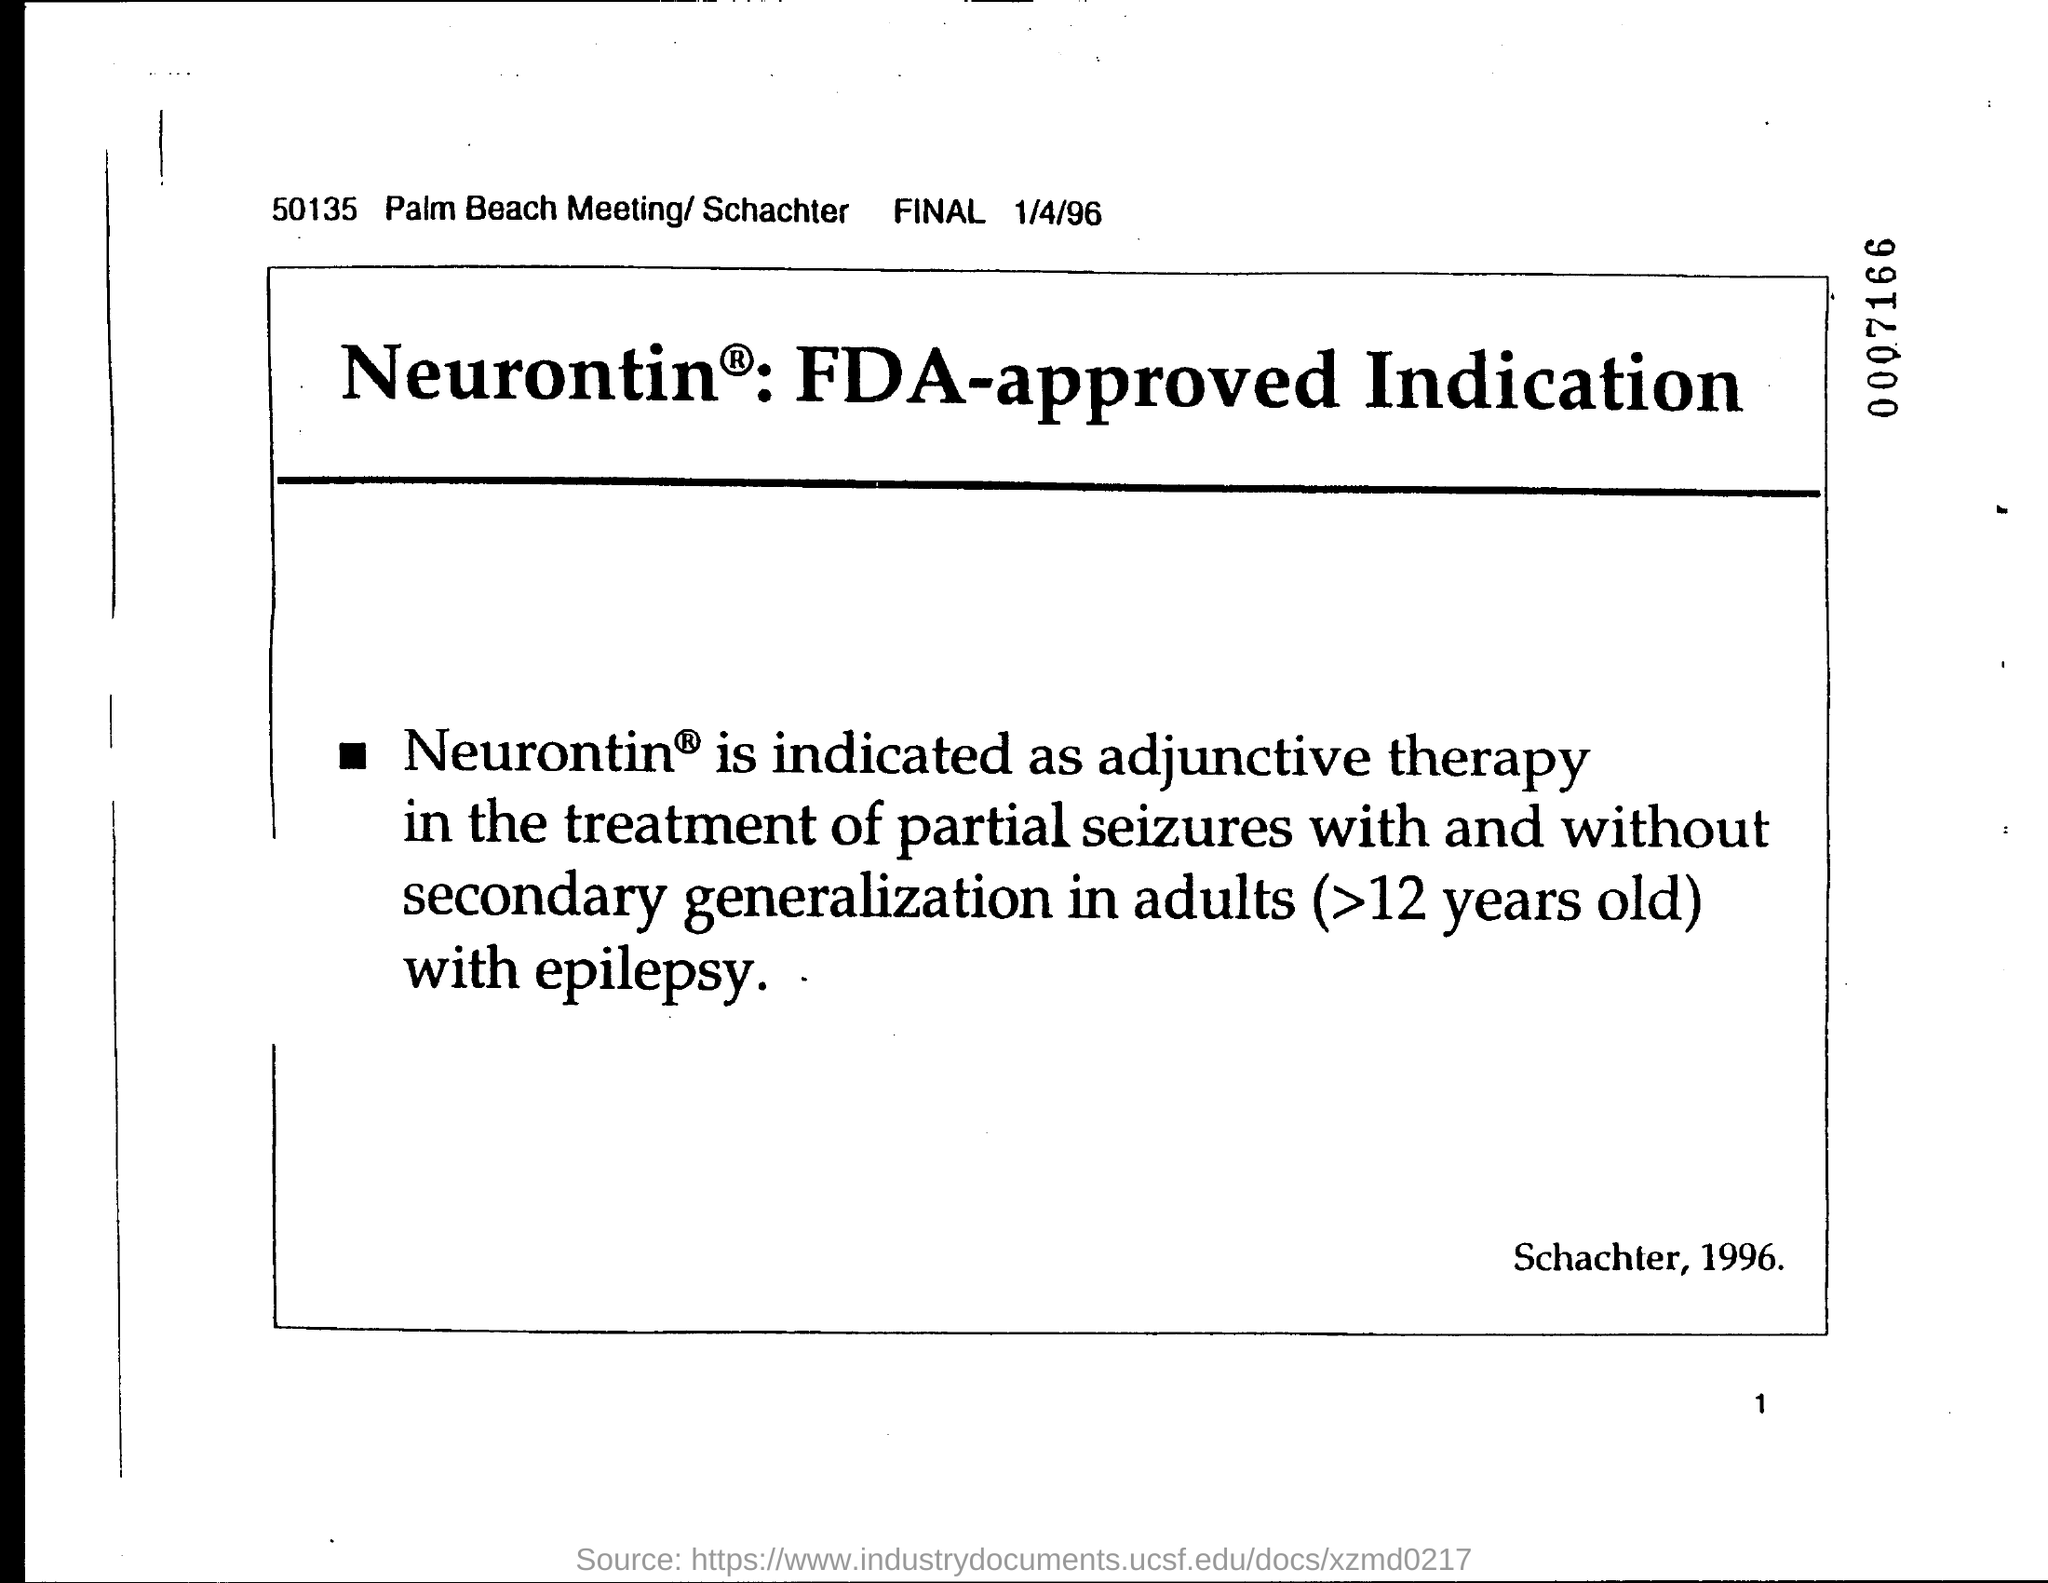Give some essential details in this illustration. I am requesting information regarding the date on the document, specifically January 4, 1996. 